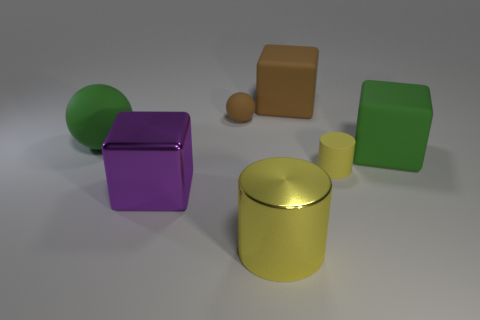Subtract all green cubes. How many cubes are left? 2 Subtract all brown blocks. How many blocks are left? 2 Subtract 1 blocks. How many blocks are left? 2 Add 1 tiny brown matte balls. How many objects exist? 8 Subtract all cylinders. How many objects are left? 5 Subtract all red spheres. How many brown cylinders are left? 0 Subtract all small brown balls. Subtract all big brown matte things. How many objects are left? 5 Add 3 big rubber blocks. How many big rubber blocks are left? 5 Add 5 small yellow spheres. How many small yellow spheres exist? 5 Subtract 2 yellow cylinders. How many objects are left? 5 